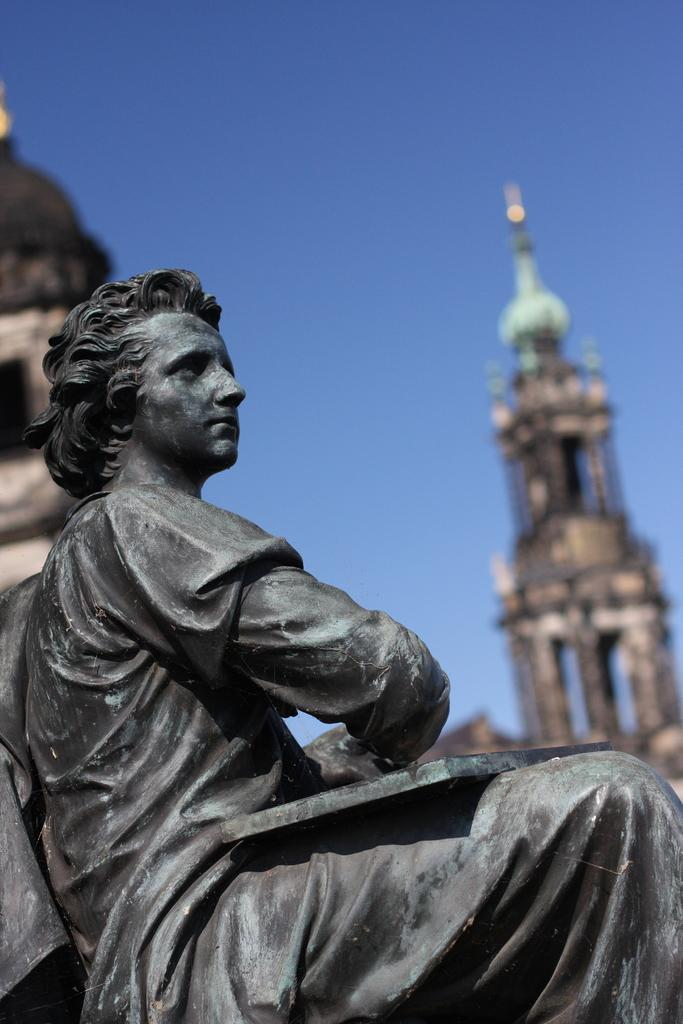What is the main subject of the image? There is a sculpture of a person in the image. What other structures or objects can be seen in the image? There is a building in the image. What part of the natural environment is visible in the image? The sky is visible in the image. How many ladybugs can be seen crawling on the sculpture in the image? There are no ladybugs present in the image; it features a sculpture of a person and a building. What type of muscle is visible on the sculpture in the image? There is no muscle visible on the sculpture in the image, as it is a sculpture of a person and not a living being. 